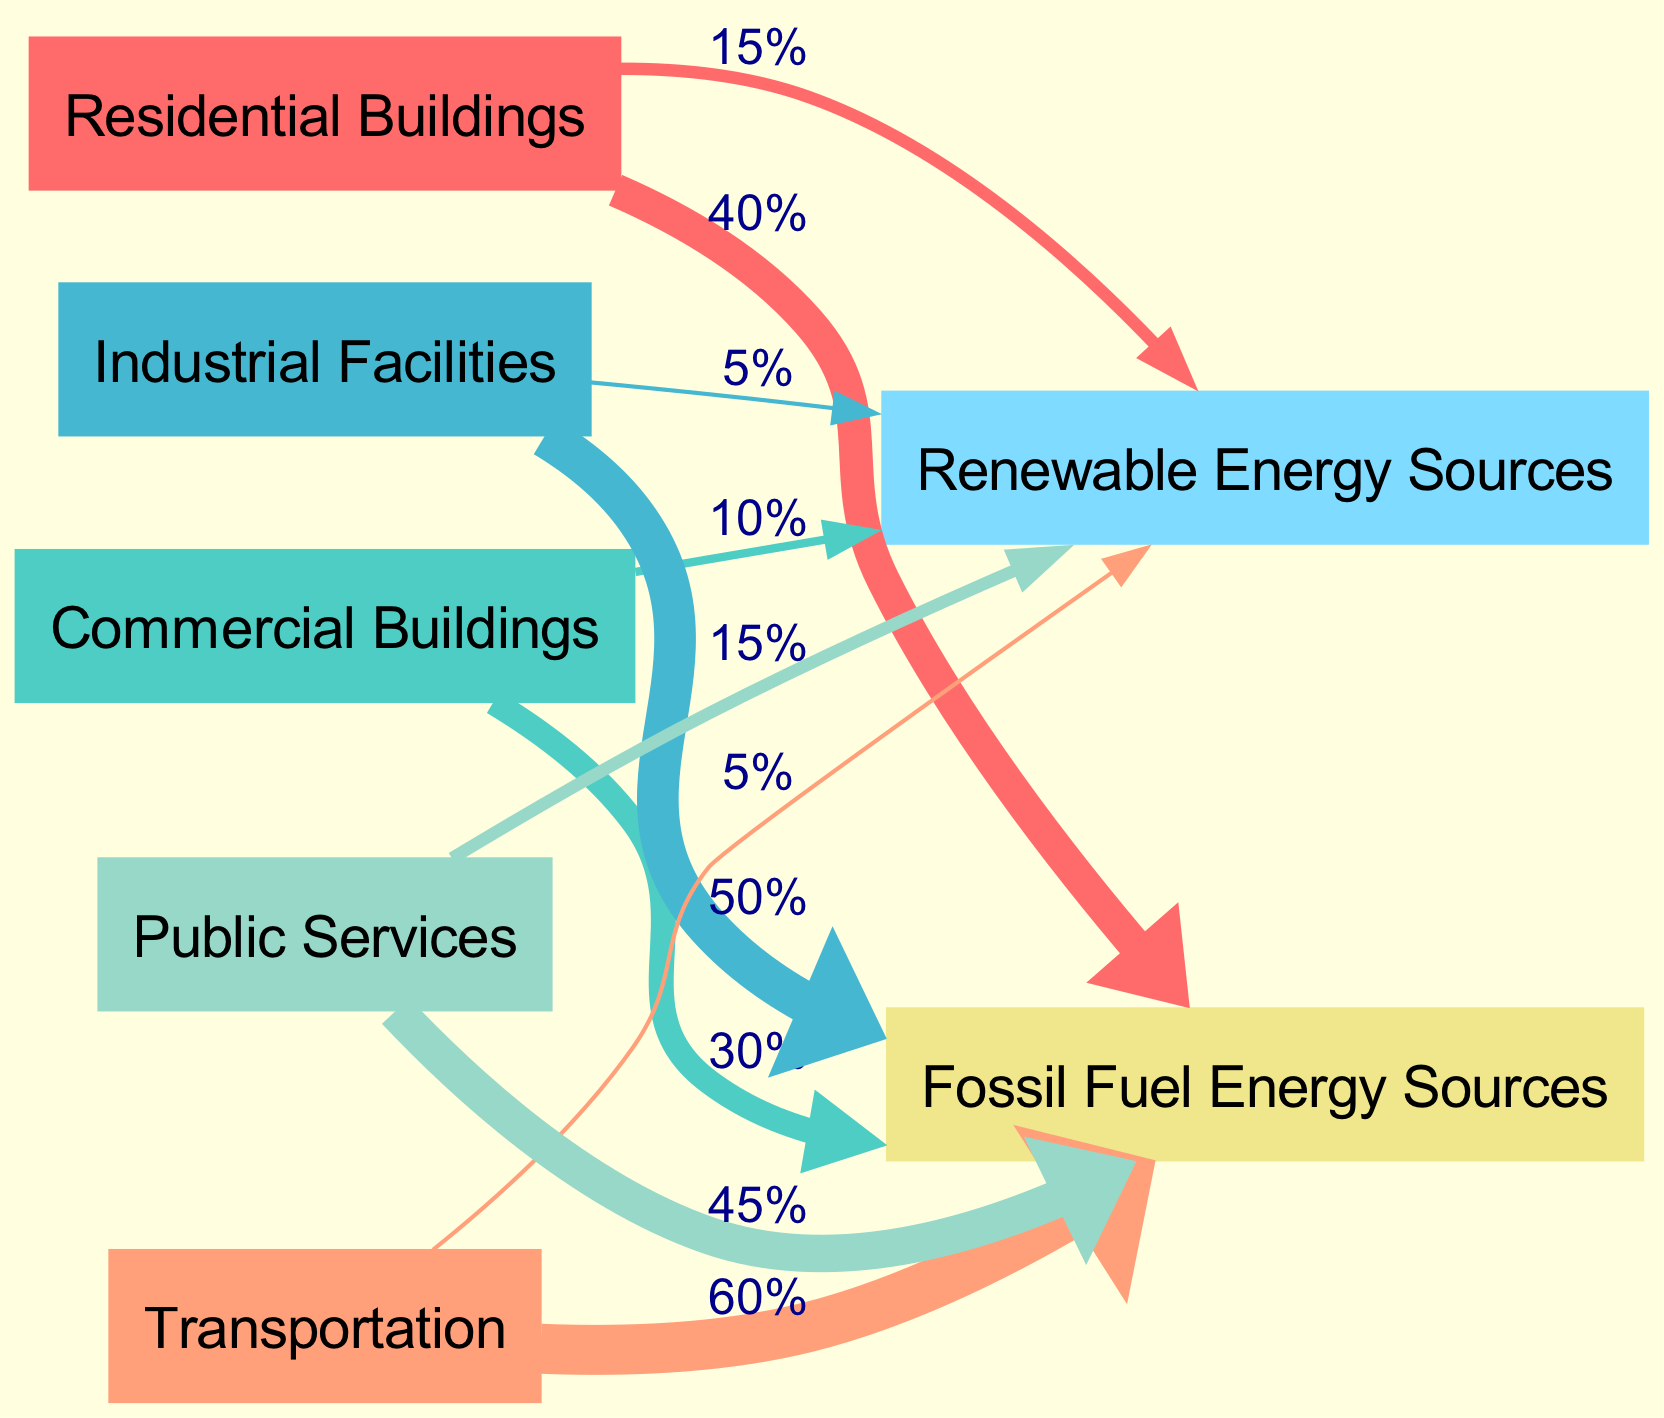What is the energy consumption percentage from Transportation to Fossil Fuel Energy Sources? In the diagram, the flow from the "Transportation" node to the "Fossil Fuel Energy Sources" node shows a value of 60%.
Answer: 60% How many nodes are present in the diagram? The diagram lists the following nodes: Residential Buildings, Commercial Buildings, Industrial Facilities, Transportation, Public Services, Renewable Energy Sources, and Fossil Fuel Energy Sources. This totals to 7 nodes.
Answer: 7 What is the total energy consumption percentage from Public Services to Renewable Energy Sources? The flow from the "Public Services" node to the "Renewable Energy Sources" node is represented by a value of 15%.
Answer: 15% Which sector has the highest energy consumption from Fossil Fuel Energy Sources? By analyzing the links, the "Transportation" sector has the highest flow to the "Fossil Fuel Energy Sources" node at 60%.
Answer: Transportation What is the combined energy consumption from Industrial Facilities to both energy sources? From the "Industrial Facilities" node, the total energy consumption is 50% to "Fossil Fuel Energy Sources" and 5% to "Renewable Energy Sources". The sum is 50% + 5% = 55%.
Answer: 55% What is the relationship between Commercial Buildings and Renewable Energy Sources? The flow from "Commercial Buildings" to "Renewable Energy Sources" is 10%, indicating a direct link illustrating energy consumption in that direction.
Answer: 10% Which sector utilizes the least amount of Renewable Energy Sources? Reviewing the flows to Renewable Energy Sources, "Industrial Facilities" shows the lowest value at 5%.
Answer: Industrial Facilities How do the energy consumption flows compare between Residential Buildings and Public Services towards Fossil Fuel Energy Sources? "Residential Buildings" consumes 40% from Fossil Fuel Energy Sources, while "Public Services" consumes 45%. Hence, Public Services has a higher flow.
Answer: Public Services 